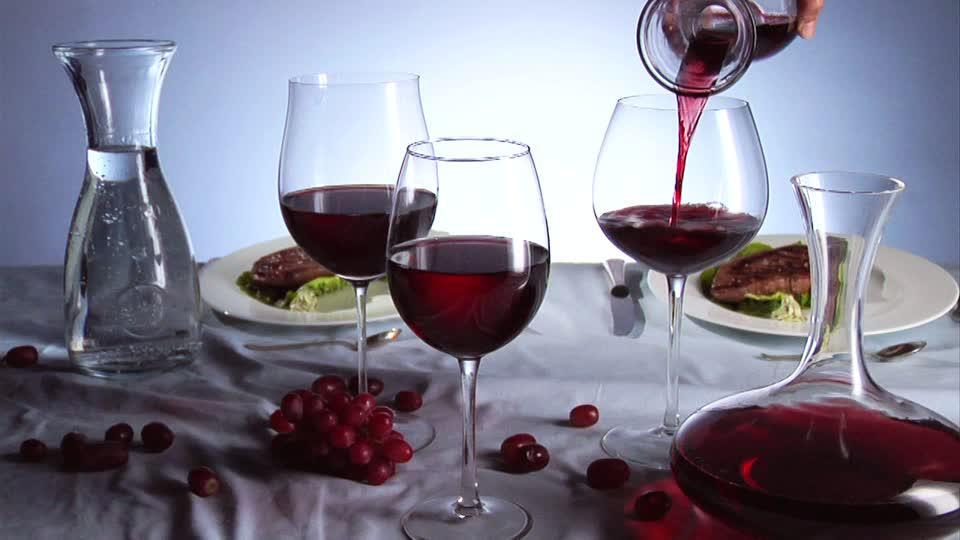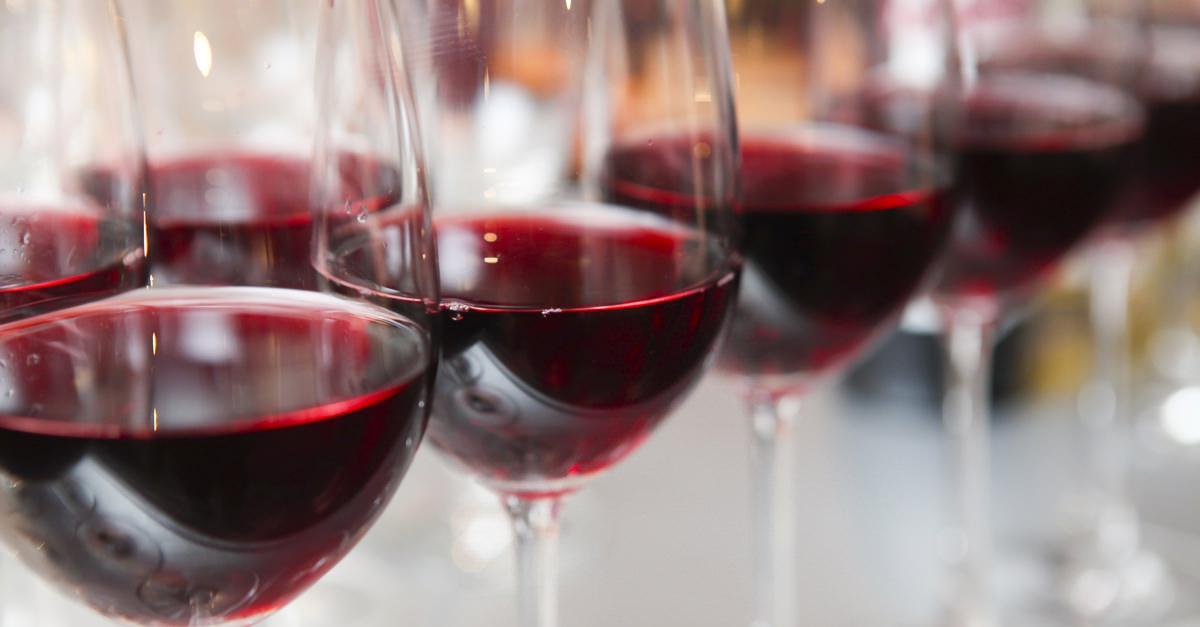The first image is the image on the left, the second image is the image on the right. For the images displayed, is the sentence "An image shows only several partly filled wine glasses." factually correct? Answer yes or no. Yes. The first image is the image on the left, the second image is the image on the right. Examine the images to the left and right. Is the description "there is a bottle of wine in the iamge on the left" accurate? Answer yes or no. No. 